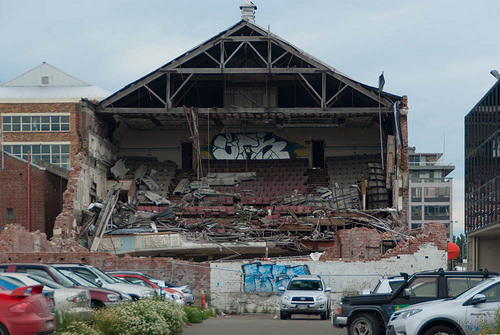<image>
Is there a car under the roof? Yes. The car is positioned underneath the roof, with the roof above it in the vertical space. 